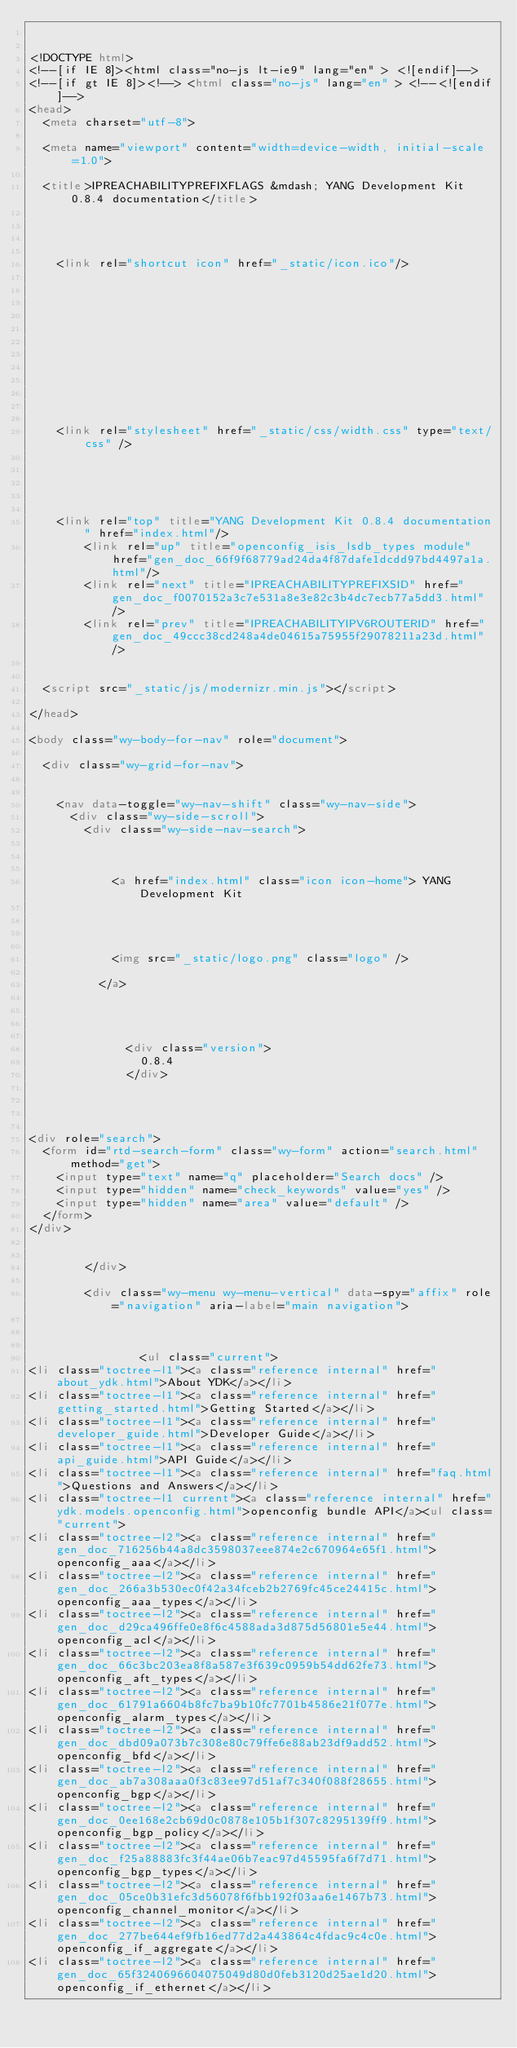Convert code to text. <code><loc_0><loc_0><loc_500><loc_500><_HTML_>

<!DOCTYPE html>
<!--[if IE 8]><html class="no-js lt-ie9" lang="en" > <![endif]-->
<!--[if gt IE 8]><!--> <html class="no-js" lang="en" > <!--<![endif]-->
<head>
  <meta charset="utf-8">
  
  <meta name="viewport" content="width=device-width, initial-scale=1.0">
  
  <title>IPREACHABILITYPREFIXFLAGS &mdash; YANG Development Kit 0.8.4 documentation</title>
  

  
  
    <link rel="shortcut icon" href="_static/icon.ico"/>
  

  

  
  
    

  

  
  
    <link rel="stylesheet" href="_static/css/width.css" type="text/css" />
  

  

  
    <link rel="top" title="YANG Development Kit 0.8.4 documentation" href="index.html"/>
        <link rel="up" title="openconfig_isis_lsdb_types module" href="gen_doc_66f9f68779ad24da4f87dafe1dcdd97bd4497a1a.html"/>
        <link rel="next" title="IPREACHABILITYPREFIXSID" href="gen_doc_f0070152a3c7e531a8e3e82c3b4dc7ecb77a5dd3.html"/>
        <link rel="prev" title="IPREACHABILITYIPV6ROUTERID" href="gen_doc_49ccc38cd248a4de04615a75955f29078211a23d.html"/> 

  
  <script src="_static/js/modernizr.min.js"></script>

</head>

<body class="wy-body-for-nav" role="document">

  <div class="wy-grid-for-nav">

    
    <nav data-toggle="wy-nav-shift" class="wy-nav-side">
      <div class="wy-side-scroll">
        <div class="wy-side-nav-search">
          

          
            <a href="index.html" class="icon icon-home"> YANG Development Kit
          

          
            
            <img src="_static/logo.png" class="logo" />
          
          </a>

          
            
            
              <div class="version">
                0.8.4
              </div>
            
          

          
<div role="search">
  <form id="rtd-search-form" class="wy-form" action="search.html" method="get">
    <input type="text" name="q" placeholder="Search docs" />
    <input type="hidden" name="check_keywords" value="yes" />
    <input type="hidden" name="area" value="default" />
  </form>
</div>

          
        </div>

        <div class="wy-menu wy-menu-vertical" data-spy="affix" role="navigation" aria-label="main navigation">
          
            
            
                <ul class="current">
<li class="toctree-l1"><a class="reference internal" href="about_ydk.html">About YDK</a></li>
<li class="toctree-l1"><a class="reference internal" href="getting_started.html">Getting Started</a></li>
<li class="toctree-l1"><a class="reference internal" href="developer_guide.html">Developer Guide</a></li>
<li class="toctree-l1"><a class="reference internal" href="api_guide.html">API Guide</a></li>
<li class="toctree-l1"><a class="reference internal" href="faq.html">Questions and Answers</a></li>
<li class="toctree-l1 current"><a class="reference internal" href="ydk.models.openconfig.html">openconfig bundle API</a><ul class="current">
<li class="toctree-l2"><a class="reference internal" href="gen_doc_716256b44a8dc3598037eee874e2c670964e65f1.html">openconfig_aaa</a></li>
<li class="toctree-l2"><a class="reference internal" href="gen_doc_266a3b530ec0f42a34fceb2b2769fc45ce24415c.html">openconfig_aaa_types</a></li>
<li class="toctree-l2"><a class="reference internal" href="gen_doc_d29ca496ffe0e8f6c4588ada3d875d56801e5e44.html">openconfig_acl</a></li>
<li class="toctree-l2"><a class="reference internal" href="gen_doc_66c3bc203ea8f8a587e3f639c0959b54dd62fe73.html">openconfig_aft_types</a></li>
<li class="toctree-l2"><a class="reference internal" href="gen_doc_61791a6604b8fc7ba9b10fc7701b4586e21f077e.html">openconfig_alarm_types</a></li>
<li class="toctree-l2"><a class="reference internal" href="gen_doc_dbd09a073b7c308e80c79ffe6e88ab23df9add52.html">openconfig_bfd</a></li>
<li class="toctree-l2"><a class="reference internal" href="gen_doc_ab7a308aaa0f3c83ee97d51af7c340f088f28655.html">openconfig_bgp</a></li>
<li class="toctree-l2"><a class="reference internal" href="gen_doc_0ee168e2cb69d0c0878e105b1f307c8295139ff9.html">openconfig_bgp_policy</a></li>
<li class="toctree-l2"><a class="reference internal" href="gen_doc_f25a88883fc3f44ae06b7eac97d45595fa6f7d71.html">openconfig_bgp_types</a></li>
<li class="toctree-l2"><a class="reference internal" href="gen_doc_05ce0b31efc3d56078f6fbb192f03aa6e1467b73.html">openconfig_channel_monitor</a></li>
<li class="toctree-l2"><a class="reference internal" href="gen_doc_277be644ef9fb16ed77d2a443864c4fdac9c4c0e.html">openconfig_if_aggregate</a></li>
<li class="toctree-l2"><a class="reference internal" href="gen_doc_65f3240696604075049d80d0feb3120d25ae1d20.html">openconfig_if_ethernet</a></li></code> 